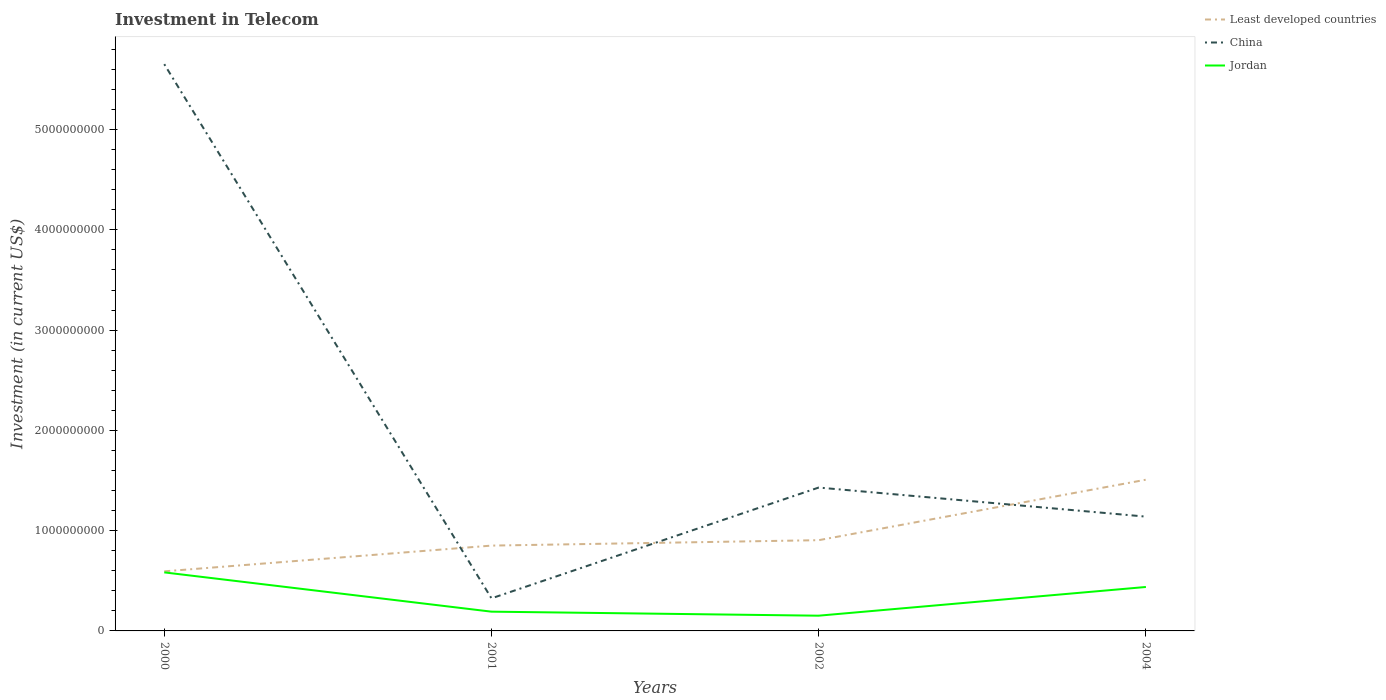How many different coloured lines are there?
Provide a succinct answer. 3. Does the line corresponding to Least developed countries intersect with the line corresponding to China?
Keep it short and to the point. Yes. Is the number of lines equal to the number of legend labels?
Your response must be concise. Yes. Across all years, what is the maximum amount invested in telecom in China?
Ensure brevity in your answer.  3.25e+08. What is the total amount invested in telecom in Least developed countries in the graph?
Ensure brevity in your answer.  -6.03e+08. What is the difference between the highest and the second highest amount invested in telecom in China?
Ensure brevity in your answer.  5.33e+09. What is the difference between the highest and the lowest amount invested in telecom in Jordan?
Make the answer very short. 2. Is the amount invested in telecom in China strictly greater than the amount invested in telecom in Jordan over the years?
Your response must be concise. No. How many lines are there?
Offer a terse response. 3. How many years are there in the graph?
Your answer should be very brief. 4. Are the values on the major ticks of Y-axis written in scientific E-notation?
Ensure brevity in your answer.  No. Does the graph contain any zero values?
Give a very brief answer. No. Where does the legend appear in the graph?
Your response must be concise. Top right. How are the legend labels stacked?
Your response must be concise. Vertical. What is the title of the graph?
Offer a very short reply. Investment in Telecom. What is the label or title of the X-axis?
Your response must be concise. Years. What is the label or title of the Y-axis?
Provide a short and direct response. Investment (in current US$). What is the Investment (in current US$) of Least developed countries in 2000?
Offer a very short reply. 5.94e+08. What is the Investment (in current US$) of China in 2000?
Keep it short and to the point. 5.65e+09. What is the Investment (in current US$) of Jordan in 2000?
Offer a very short reply. 5.84e+08. What is the Investment (in current US$) in Least developed countries in 2001?
Offer a terse response. 8.51e+08. What is the Investment (in current US$) in China in 2001?
Ensure brevity in your answer.  3.25e+08. What is the Investment (in current US$) of Jordan in 2001?
Keep it short and to the point. 1.92e+08. What is the Investment (in current US$) in Least developed countries in 2002?
Offer a very short reply. 9.05e+08. What is the Investment (in current US$) of China in 2002?
Make the answer very short. 1.43e+09. What is the Investment (in current US$) in Jordan in 2002?
Offer a very short reply. 1.52e+08. What is the Investment (in current US$) in Least developed countries in 2004?
Your answer should be compact. 1.51e+09. What is the Investment (in current US$) of China in 2004?
Offer a terse response. 1.14e+09. What is the Investment (in current US$) of Jordan in 2004?
Your response must be concise. 4.38e+08. Across all years, what is the maximum Investment (in current US$) in Least developed countries?
Offer a terse response. 1.51e+09. Across all years, what is the maximum Investment (in current US$) of China?
Keep it short and to the point. 5.65e+09. Across all years, what is the maximum Investment (in current US$) in Jordan?
Keep it short and to the point. 5.84e+08. Across all years, what is the minimum Investment (in current US$) in Least developed countries?
Provide a short and direct response. 5.94e+08. Across all years, what is the minimum Investment (in current US$) in China?
Provide a short and direct response. 3.25e+08. Across all years, what is the minimum Investment (in current US$) of Jordan?
Your answer should be very brief. 1.52e+08. What is the total Investment (in current US$) in Least developed countries in the graph?
Keep it short and to the point. 3.86e+09. What is the total Investment (in current US$) of China in the graph?
Provide a short and direct response. 8.55e+09. What is the total Investment (in current US$) in Jordan in the graph?
Offer a very short reply. 1.37e+09. What is the difference between the Investment (in current US$) in Least developed countries in 2000 and that in 2001?
Keep it short and to the point. -2.57e+08. What is the difference between the Investment (in current US$) of China in 2000 and that in 2001?
Your response must be concise. 5.33e+09. What is the difference between the Investment (in current US$) in Jordan in 2000 and that in 2001?
Provide a succinct answer. 3.92e+08. What is the difference between the Investment (in current US$) of Least developed countries in 2000 and that in 2002?
Give a very brief answer. -3.11e+08. What is the difference between the Investment (in current US$) in China in 2000 and that in 2002?
Ensure brevity in your answer.  4.22e+09. What is the difference between the Investment (in current US$) of Jordan in 2000 and that in 2002?
Make the answer very short. 4.32e+08. What is the difference between the Investment (in current US$) in Least developed countries in 2000 and that in 2004?
Keep it short and to the point. -9.14e+08. What is the difference between the Investment (in current US$) of China in 2000 and that in 2004?
Your response must be concise. 4.51e+09. What is the difference between the Investment (in current US$) in Jordan in 2000 and that in 2004?
Provide a short and direct response. 1.46e+08. What is the difference between the Investment (in current US$) in Least developed countries in 2001 and that in 2002?
Provide a succinct answer. -5.40e+07. What is the difference between the Investment (in current US$) of China in 2001 and that in 2002?
Provide a short and direct response. -1.10e+09. What is the difference between the Investment (in current US$) of Jordan in 2001 and that in 2002?
Ensure brevity in your answer.  4.01e+07. What is the difference between the Investment (in current US$) of Least developed countries in 2001 and that in 2004?
Provide a succinct answer. -6.57e+08. What is the difference between the Investment (in current US$) in China in 2001 and that in 2004?
Give a very brief answer. -8.15e+08. What is the difference between the Investment (in current US$) in Jordan in 2001 and that in 2004?
Ensure brevity in your answer.  -2.46e+08. What is the difference between the Investment (in current US$) of Least developed countries in 2002 and that in 2004?
Provide a succinct answer. -6.03e+08. What is the difference between the Investment (in current US$) of China in 2002 and that in 2004?
Ensure brevity in your answer.  2.90e+08. What is the difference between the Investment (in current US$) in Jordan in 2002 and that in 2004?
Keep it short and to the point. -2.86e+08. What is the difference between the Investment (in current US$) of Least developed countries in 2000 and the Investment (in current US$) of China in 2001?
Provide a short and direct response. 2.69e+08. What is the difference between the Investment (in current US$) in Least developed countries in 2000 and the Investment (in current US$) in Jordan in 2001?
Your answer should be compact. 4.02e+08. What is the difference between the Investment (in current US$) of China in 2000 and the Investment (in current US$) of Jordan in 2001?
Offer a terse response. 5.46e+09. What is the difference between the Investment (in current US$) in Least developed countries in 2000 and the Investment (in current US$) in China in 2002?
Your response must be concise. -8.36e+08. What is the difference between the Investment (in current US$) in Least developed countries in 2000 and the Investment (in current US$) in Jordan in 2002?
Make the answer very short. 4.42e+08. What is the difference between the Investment (in current US$) in China in 2000 and the Investment (in current US$) in Jordan in 2002?
Offer a very short reply. 5.50e+09. What is the difference between the Investment (in current US$) of Least developed countries in 2000 and the Investment (in current US$) of China in 2004?
Your answer should be compact. -5.46e+08. What is the difference between the Investment (in current US$) of Least developed countries in 2000 and the Investment (in current US$) of Jordan in 2004?
Your answer should be very brief. 1.56e+08. What is the difference between the Investment (in current US$) of China in 2000 and the Investment (in current US$) of Jordan in 2004?
Provide a short and direct response. 5.21e+09. What is the difference between the Investment (in current US$) of Least developed countries in 2001 and the Investment (in current US$) of China in 2002?
Offer a terse response. -5.79e+08. What is the difference between the Investment (in current US$) of Least developed countries in 2001 and the Investment (in current US$) of Jordan in 2002?
Offer a very short reply. 6.99e+08. What is the difference between the Investment (in current US$) of China in 2001 and the Investment (in current US$) of Jordan in 2002?
Your answer should be compact. 1.73e+08. What is the difference between the Investment (in current US$) in Least developed countries in 2001 and the Investment (in current US$) in China in 2004?
Give a very brief answer. -2.89e+08. What is the difference between the Investment (in current US$) in Least developed countries in 2001 and the Investment (in current US$) in Jordan in 2004?
Provide a succinct answer. 4.13e+08. What is the difference between the Investment (in current US$) of China in 2001 and the Investment (in current US$) of Jordan in 2004?
Your response must be concise. -1.13e+08. What is the difference between the Investment (in current US$) of Least developed countries in 2002 and the Investment (in current US$) of China in 2004?
Make the answer very short. -2.35e+08. What is the difference between the Investment (in current US$) in Least developed countries in 2002 and the Investment (in current US$) in Jordan in 2004?
Your answer should be compact. 4.67e+08. What is the difference between the Investment (in current US$) in China in 2002 and the Investment (in current US$) in Jordan in 2004?
Provide a short and direct response. 9.92e+08. What is the average Investment (in current US$) in Least developed countries per year?
Provide a short and direct response. 9.65e+08. What is the average Investment (in current US$) of China per year?
Give a very brief answer. 2.14e+09. What is the average Investment (in current US$) in Jordan per year?
Your response must be concise. 3.42e+08. In the year 2000, what is the difference between the Investment (in current US$) in Least developed countries and Investment (in current US$) in China?
Make the answer very short. -5.06e+09. In the year 2000, what is the difference between the Investment (in current US$) in Least developed countries and Investment (in current US$) in Jordan?
Keep it short and to the point. 1.04e+07. In the year 2000, what is the difference between the Investment (in current US$) in China and Investment (in current US$) in Jordan?
Your response must be concise. 5.07e+09. In the year 2001, what is the difference between the Investment (in current US$) in Least developed countries and Investment (in current US$) in China?
Ensure brevity in your answer.  5.26e+08. In the year 2001, what is the difference between the Investment (in current US$) in Least developed countries and Investment (in current US$) in Jordan?
Your answer should be compact. 6.59e+08. In the year 2001, what is the difference between the Investment (in current US$) in China and Investment (in current US$) in Jordan?
Offer a terse response. 1.33e+08. In the year 2002, what is the difference between the Investment (in current US$) in Least developed countries and Investment (in current US$) in China?
Provide a short and direct response. -5.25e+08. In the year 2002, what is the difference between the Investment (in current US$) of Least developed countries and Investment (in current US$) of Jordan?
Give a very brief answer. 7.53e+08. In the year 2002, what is the difference between the Investment (in current US$) of China and Investment (in current US$) of Jordan?
Your answer should be compact. 1.28e+09. In the year 2004, what is the difference between the Investment (in current US$) of Least developed countries and Investment (in current US$) of China?
Your response must be concise. 3.68e+08. In the year 2004, what is the difference between the Investment (in current US$) in Least developed countries and Investment (in current US$) in Jordan?
Offer a terse response. 1.07e+09. In the year 2004, what is the difference between the Investment (in current US$) of China and Investment (in current US$) of Jordan?
Provide a succinct answer. 7.02e+08. What is the ratio of the Investment (in current US$) in Least developed countries in 2000 to that in 2001?
Make the answer very short. 0.7. What is the ratio of the Investment (in current US$) of China in 2000 to that in 2001?
Make the answer very short. 17.39. What is the ratio of the Investment (in current US$) in Jordan in 2000 to that in 2001?
Offer a very short reply. 3.04. What is the ratio of the Investment (in current US$) of Least developed countries in 2000 to that in 2002?
Give a very brief answer. 0.66. What is the ratio of the Investment (in current US$) of China in 2000 to that in 2002?
Make the answer very short. 3.95. What is the ratio of the Investment (in current US$) in Jordan in 2000 to that in 2002?
Your response must be concise. 3.84. What is the ratio of the Investment (in current US$) of Least developed countries in 2000 to that in 2004?
Offer a very short reply. 0.39. What is the ratio of the Investment (in current US$) of China in 2000 to that in 2004?
Your answer should be very brief. 4.96. What is the ratio of the Investment (in current US$) of Jordan in 2000 to that in 2004?
Make the answer very short. 1.33. What is the ratio of the Investment (in current US$) in Least developed countries in 2001 to that in 2002?
Provide a short and direct response. 0.94. What is the ratio of the Investment (in current US$) of China in 2001 to that in 2002?
Your response must be concise. 0.23. What is the ratio of the Investment (in current US$) in Jordan in 2001 to that in 2002?
Offer a terse response. 1.26. What is the ratio of the Investment (in current US$) of Least developed countries in 2001 to that in 2004?
Ensure brevity in your answer.  0.56. What is the ratio of the Investment (in current US$) of China in 2001 to that in 2004?
Your response must be concise. 0.29. What is the ratio of the Investment (in current US$) in Jordan in 2001 to that in 2004?
Provide a succinct answer. 0.44. What is the ratio of the Investment (in current US$) in Least developed countries in 2002 to that in 2004?
Offer a very short reply. 0.6. What is the ratio of the Investment (in current US$) of China in 2002 to that in 2004?
Ensure brevity in your answer.  1.25. What is the ratio of the Investment (in current US$) of Jordan in 2002 to that in 2004?
Provide a short and direct response. 0.35. What is the difference between the highest and the second highest Investment (in current US$) of Least developed countries?
Keep it short and to the point. 6.03e+08. What is the difference between the highest and the second highest Investment (in current US$) of China?
Your answer should be compact. 4.22e+09. What is the difference between the highest and the second highest Investment (in current US$) in Jordan?
Provide a short and direct response. 1.46e+08. What is the difference between the highest and the lowest Investment (in current US$) of Least developed countries?
Ensure brevity in your answer.  9.14e+08. What is the difference between the highest and the lowest Investment (in current US$) of China?
Make the answer very short. 5.33e+09. What is the difference between the highest and the lowest Investment (in current US$) of Jordan?
Make the answer very short. 4.32e+08. 